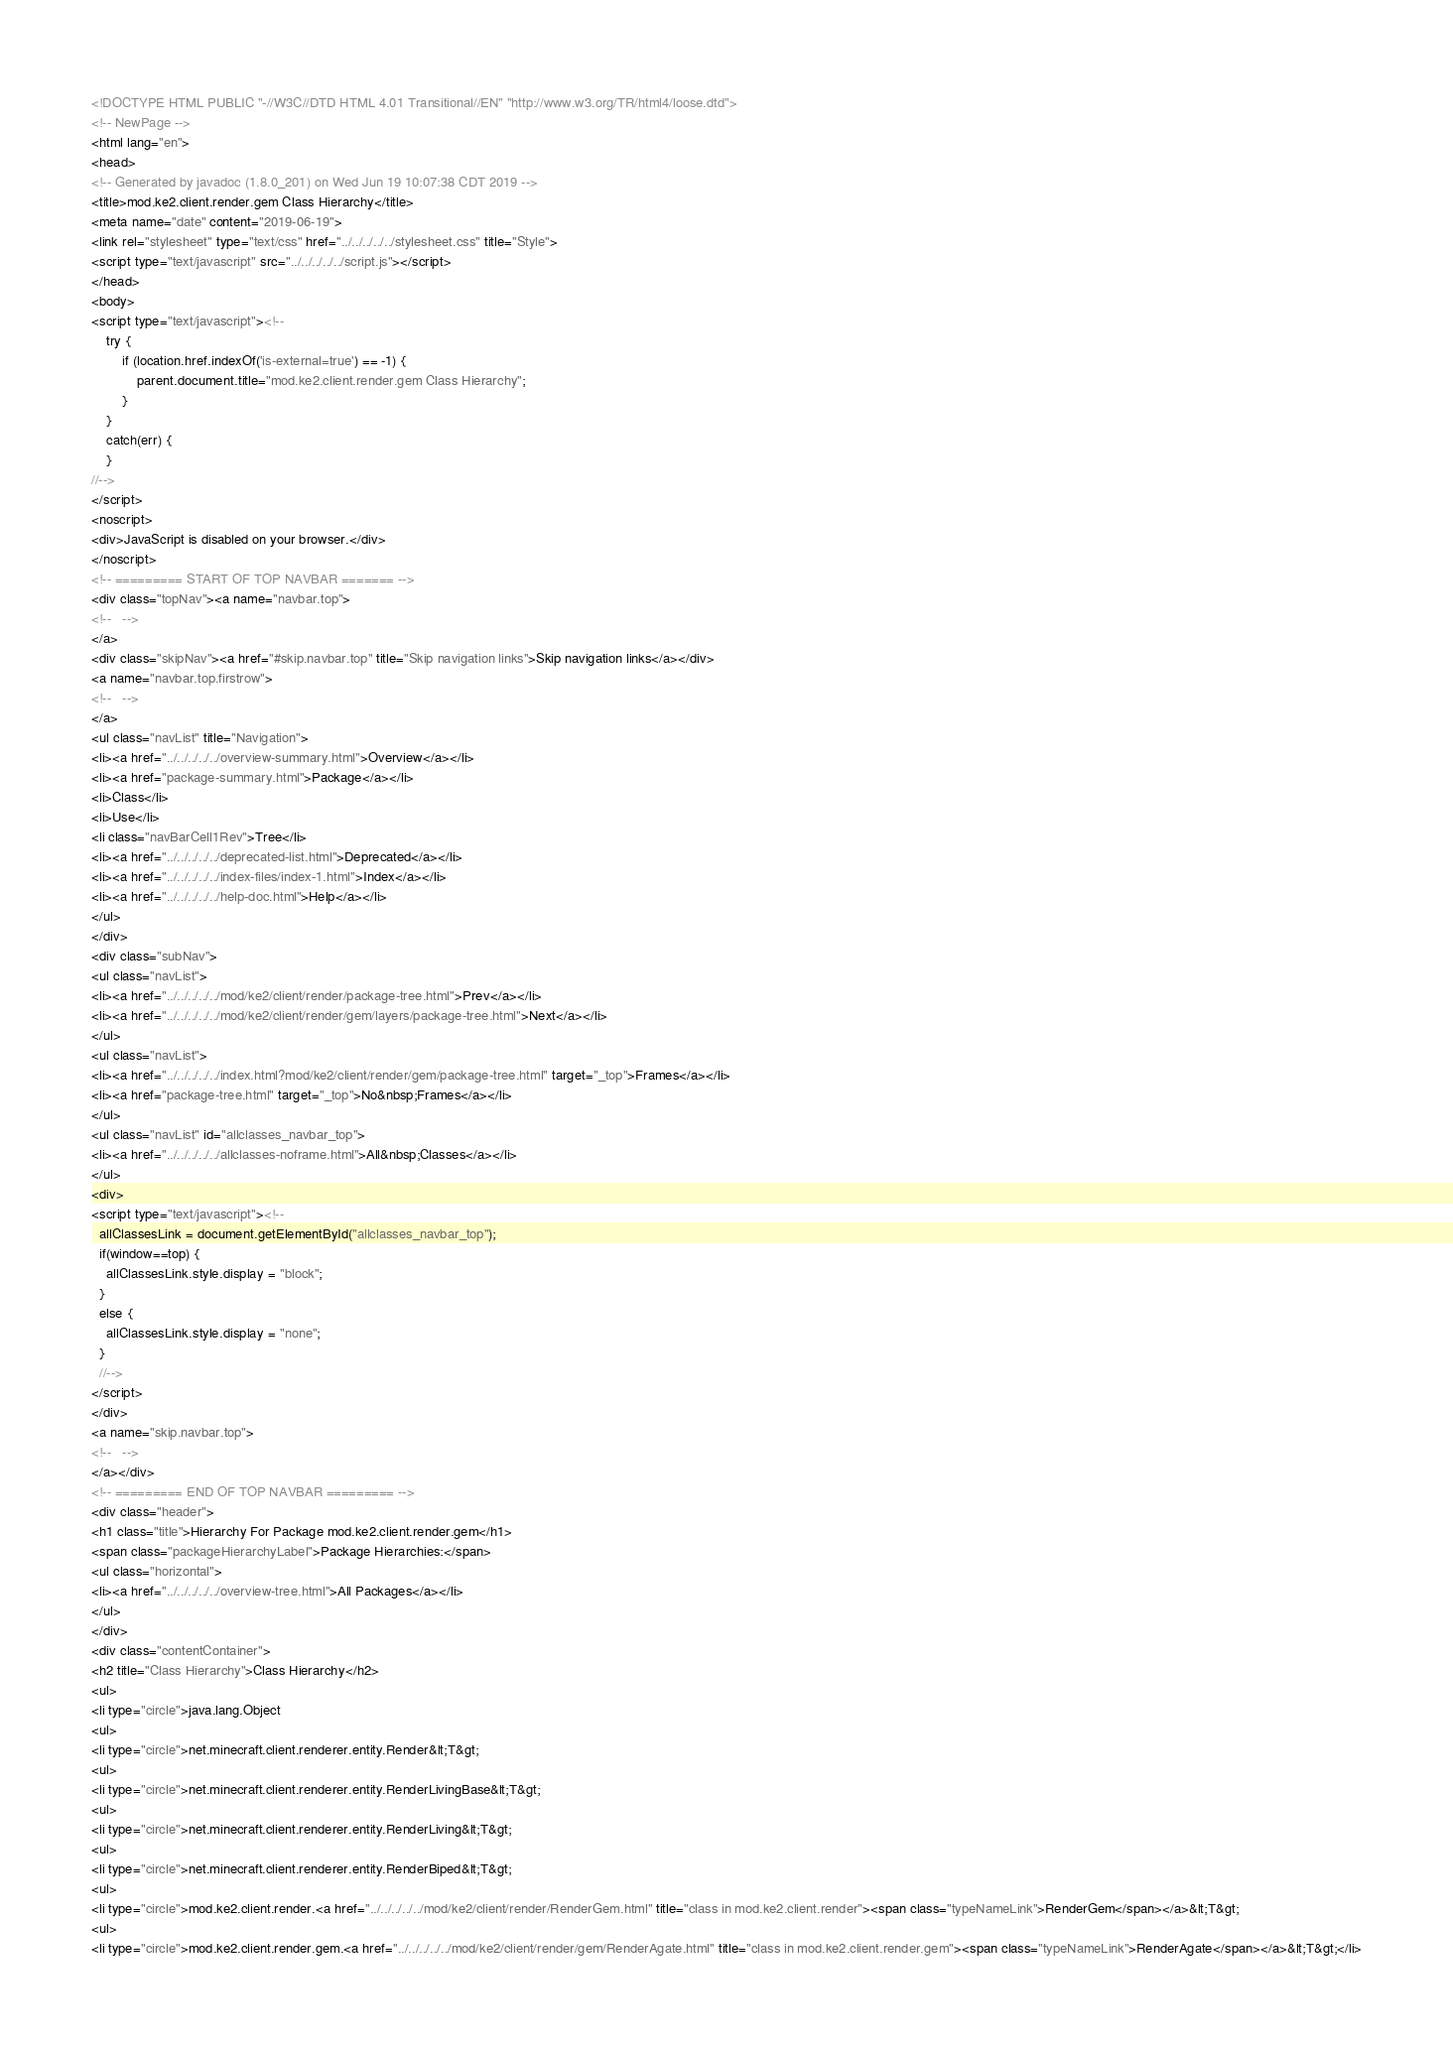Convert code to text. <code><loc_0><loc_0><loc_500><loc_500><_HTML_><!DOCTYPE HTML PUBLIC "-//W3C//DTD HTML 4.01 Transitional//EN" "http://www.w3.org/TR/html4/loose.dtd">
<!-- NewPage -->
<html lang="en">
<head>
<!-- Generated by javadoc (1.8.0_201) on Wed Jun 19 10:07:38 CDT 2019 -->
<title>mod.ke2.client.render.gem Class Hierarchy</title>
<meta name="date" content="2019-06-19">
<link rel="stylesheet" type="text/css" href="../../../../../stylesheet.css" title="Style">
<script type="text/javascript" src="../../../../../script.js"></script>
</head>
<body>
<script type="text/javascript"><!--
    try {
        if (location.href.indexOf('is-external=true') == -1) {
            parent.document.title="mod.ke2.client.render.gem Class Hierarchy";
        }
    }
    catch(err) {
    }
//-->
</script>
<noscript>
<div>JavaScript is disabled on your browser.</div>
</noscript>
<!-- ========= START OF TOP NAVBAR ======= -->
<div class="topNav"><a name="navbar.top">
<!--   -->
</a>
<div class="skipNav"><a href="#skip.navbar.top" title="Skip navigation links">Skip navigation links</a></div>
<a name="navbar.top.firstrow">
<!--   -->
</a>
<ul class="navList" title="Navigation">
<li><a href="../../../../../overview-summary.html">Overview</a></li>
<li><a href="package-summary.html">Package</a></li>
<li>Class</li>
<li>Use</li>
<li class="navBarCell1Rev">Tree</li>
<li><a href="../../../../../deprecated-list.html">Deprecated</a></li>
<li><a href="../../../../../index-files/index-1.html">Index</a></li>
<li><a href="../../../../../help-doc.html">Help</a></li>
</ul>
</div>
<div class="subNav">
<ul class="navList">
<li><a href="../../../../../mod/ke2/client/render/package-tree.html">Prev</a></li>
<li><a href="../../../../../mod/ke2/client/render/gem/layers/package-tree.html">Next</a></li>
</ul>
<ul class="navList">
<li><a href="../../../../../index.html?mod/ke2/client/render/gem/package-tree.html" target="_top">Frames</a></li>
<li><a href="package-tree.html" target="_top">No&nbsp;Frames</a></li>
</ul>
<ul class="navList" id="allclasses_navbar_top">
<li><a href="../../../../../allclasses-noframe.html">All&nbsp;Classes</a></li>
</ul>
<div>
<script type="text/javascript"><!--
  allClassesLink = document.getElementById("allclasses_navbar_top");
  if(window==top) {
    allClassesLink.style.display = "block";
  }
  else {
    allClassesLink.style.display = "none";
  }
  //-->
</script>
</div>
<a name="skip.navbar.top">
<!--   -->
</a></div>
<!-- ========= END OF TOP NAVBAR ========= -->
<div class="header">
<h1 class="title">Hierarchy For Package mod.ke2.client.render.gem</h1>
<span class="packageHierarchyLabel">Package Hierarchies:</span>
<ul class="horizontal">
<li><a href="../../../../../overview-tree.html">All Packages</a></li>
</ul>
</div>
<div class="contentContainer">
<h2 title="Class Hierarchy">Class Hierarchy</h2>
<ul>
<li type="circle">java.lang.Object
<ul>
<li type="circle">net.minecraft.client.renderer.entity.Render&lt;T&gt;
<ul>
<li type="circle">net.minecraft.client.renderer.entity.RenderLivingBase&lt;T&gt;
<ul>
<li type="circle">net.minecraft.client.renderer.entity.RenderLiving&lt;T&gt;
<ul>
<li type="circle">net.minecraft.client.renderer.entity.RenderBiped&lt;T&gt;
<ul>
<li type="circle">mod.ke2.client.render.<a href="../../../../../mod/ke2/client/render/RenderGem.html" title="class in mod.ke2.client.render"><span class="typeNameLink">RenderGem</span></a>&lt;T&gt;
<ul>
<li type="circle">mod.ke2.client.render.gem.<a href="../../../../../mod/ke2/client/render/gem/RenderAgate.html" title="class in mod.ke2.client.render.gem"><span class="typeNameLink">RenderAgate</span></a>&lt;T&gt;</li></code> 